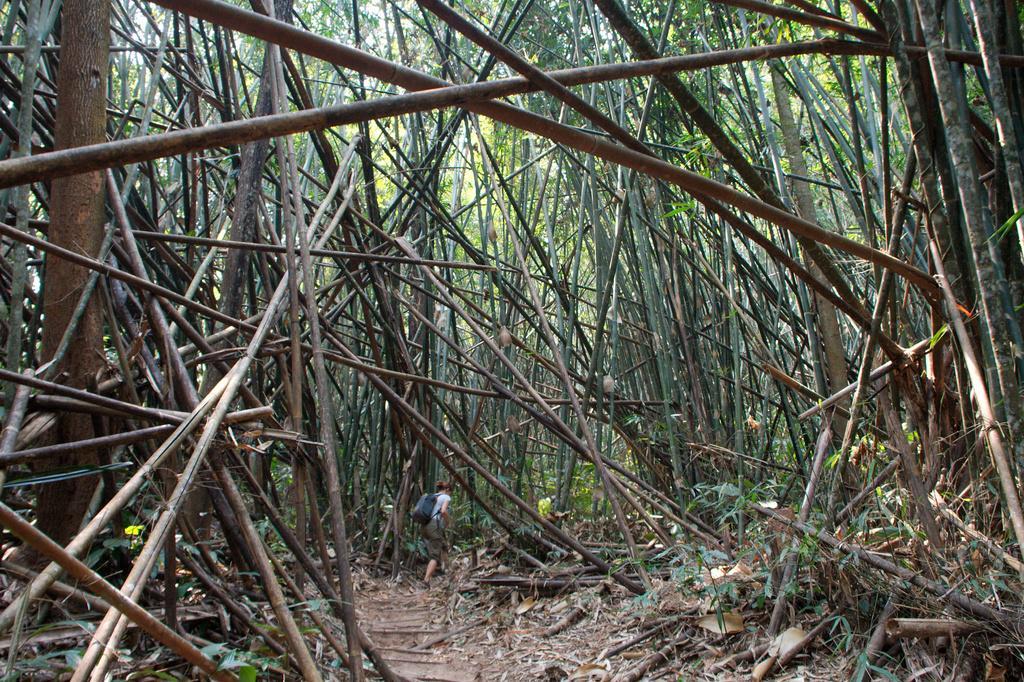In one or two sentences, can you explain what this image depicts? As we can see in the image there are dry bamboo sticks, dry grass and a woman wearing blue color bag. In the background there are trees. 